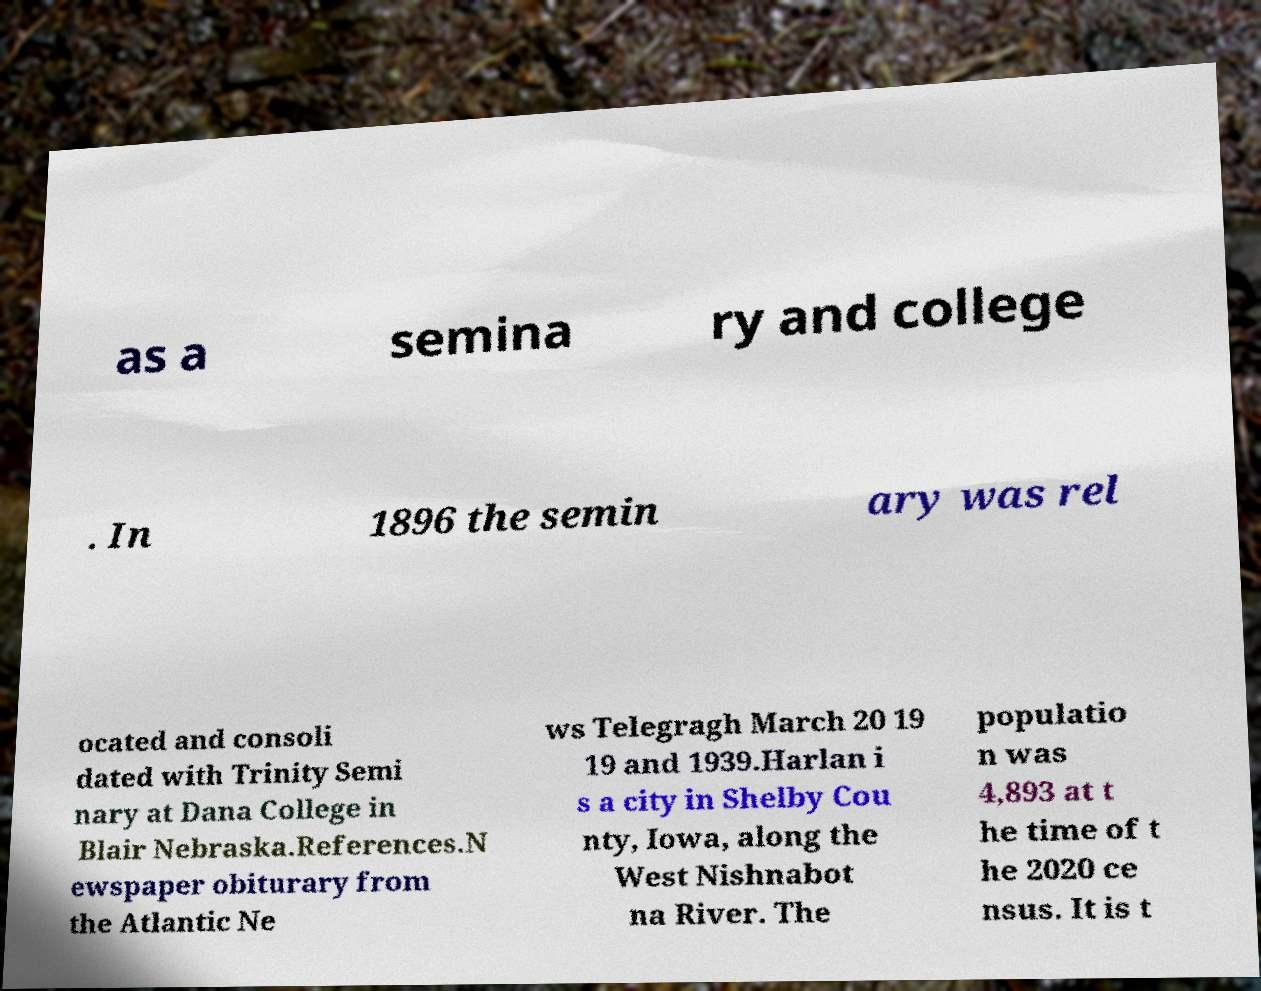Can you accurately transcribe the text from the provided image for me? as a semina ry and college . In 1896 the semin ary was rel ocated and consoli dated with Trinity Semi nary at Dana College in Blair Nebraska.References.N ewspaper obiturary from the Atlantic Ne ws Telegragh March 20 19 19 and 1939.Harlan i s a city in Shelby Cou nty, Iowa, along the West Nishnabot na River. The populatio n was 4,893 at t he time of t he 2020 ce nsus. It is t 